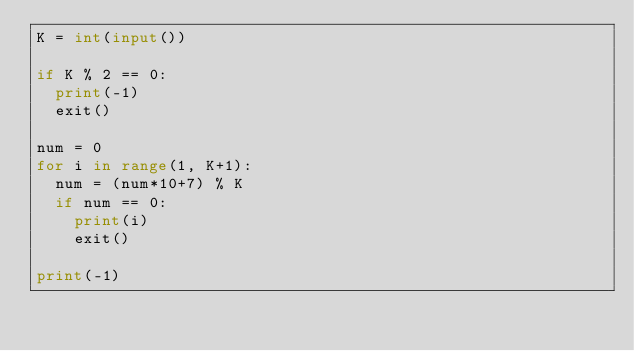Convert code to text. <code><loc_0><loc_0><loc_500><loc_500><_Python_>K = int(input())
 
if K % 2 == 0:
  print(-1)
  exit()

num = 0
for i in range(1, K+1):
  num = (num*10+7) % K
  if num == 0:
    print(i)
    exit()

print(-1)</code> 